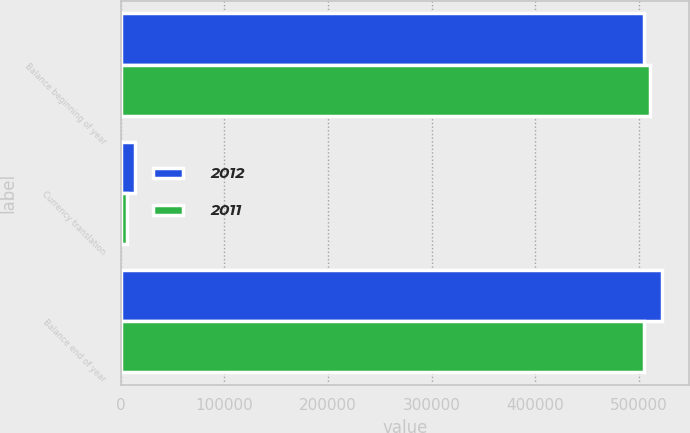<chart> <loc_0><loc_0><loc_500><loc_500><stacked_bar_chart><ecel><fcel>Balance beginning of year<fcel>Currency translation<fcel>Balance end of year<nl><fcel>2012<fcel>504784<fcel>13426<fcel>522672<nl><fcel>2011<fcel>510894<fcel>6110<fcel>504784<nl></chart> 